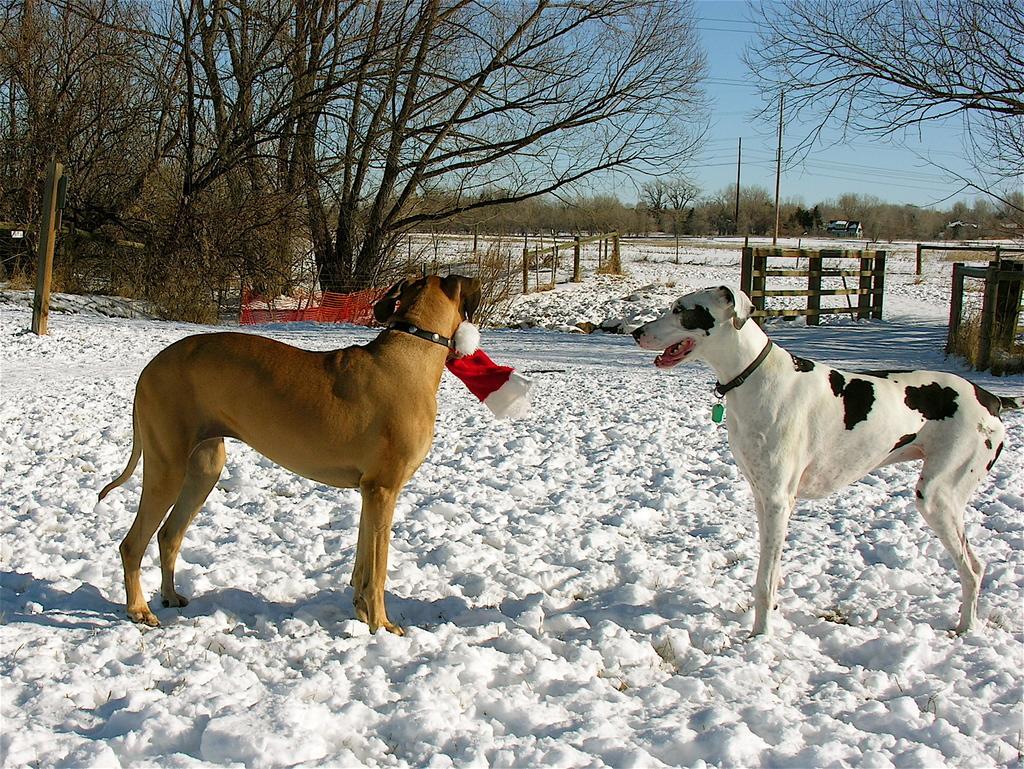Describe this image in one or two sentences. In this image I can see two dogs are standing on the snow. In the background, I can see the trees, poles and vehicles. On the top of the image I can see the sky. 